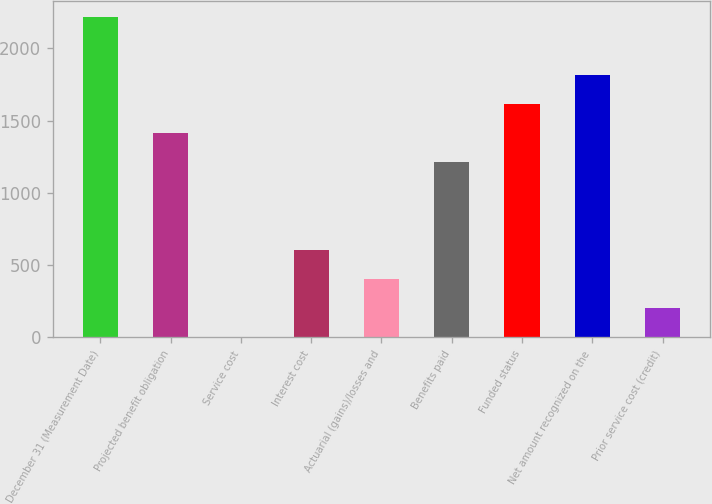<chart> <loc_0><loc_0><loc_500><loc_500><bar_chart><fcel>December 31 (Measurement Date)<fcel>Projected benefit obligation<fcel>Service cost<fcel>Interest cost<fcel>Actuarial (gains)/losses and<fcel>Benefits paid<fcel>Funded status<fcel>Net amount recognized on the<fcel>Prior service cost (credit)<nl><fcel>2213.7<fcel>1410.9<fcel>6<fcel>608.1<fcel>407.4<fcel>1210.2<fcel>1611.6<fcel>1812.3<fcel>206.7<nl></chart> 